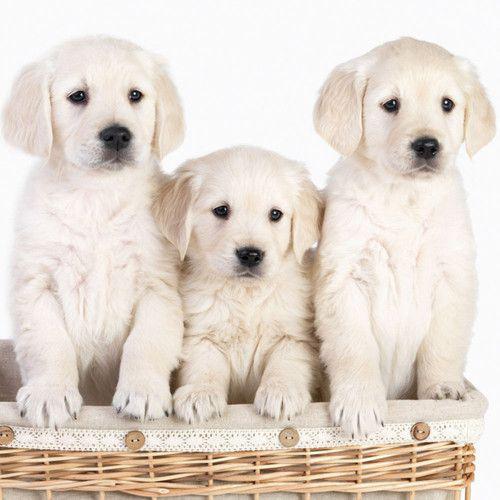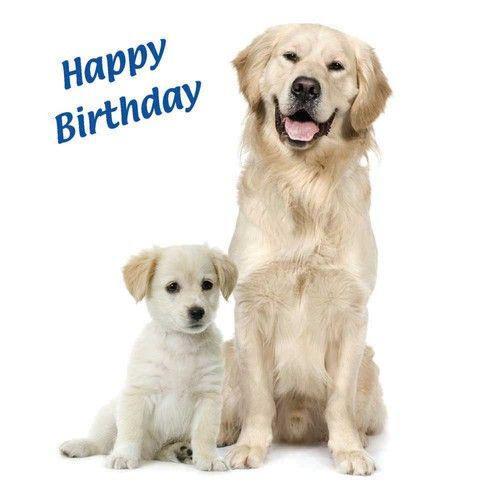The first image is the image on the left, the second image is the image on the right. Examine the images to the left and right. Is the description "The left image shows a total of 3 dogs" accurate? Answer yes or no. Yes. The first image is the image on the left, the second image is the image on the right. Considering the images on both sides, is "there are exactly three animals in the image on the left" valid? Answer yes or no. Yes. 